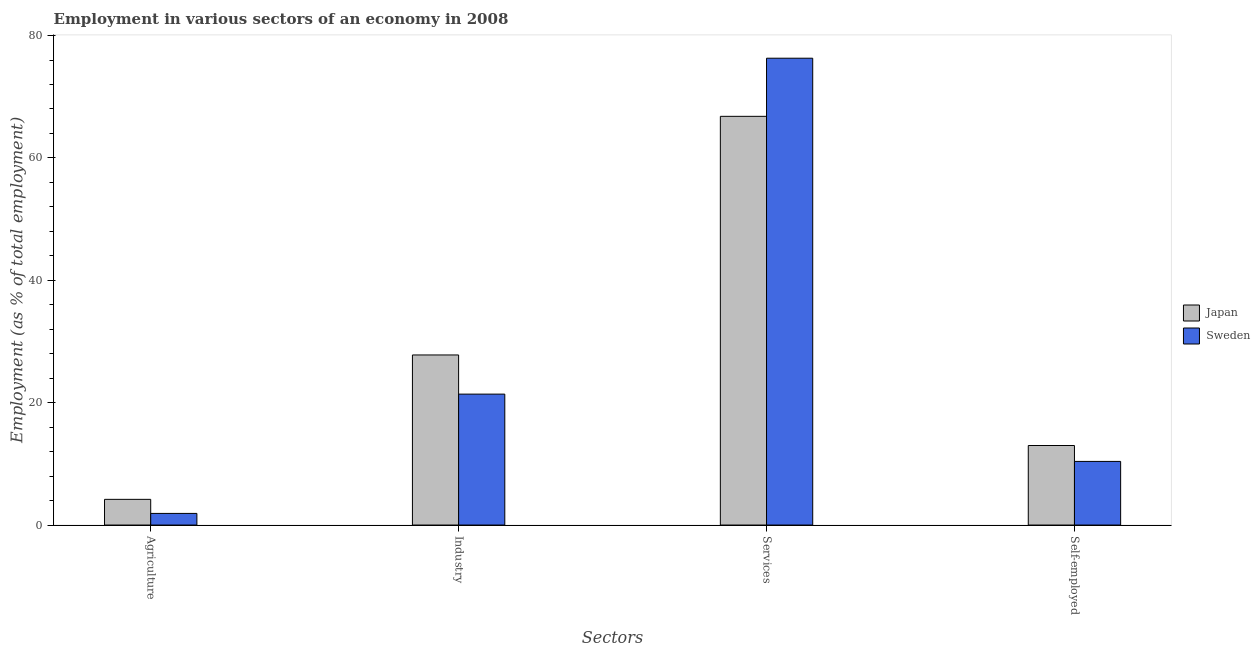How many different coloured bars are there?
Offer a terse response. 2. How many groups of bars are there?
Ensure brevity in your answer.  4. Are the number of bars per tick equal to the number of legend labels?
Your response must be concise. Yes. How many bars are there on the 2nd tick from the right?
Your response must be concise. 2. What is the label of the 3rd group of bars from the left?
Your answer should be very brief. Services. What is the percentage of workers in services in Sweden?
Ensure brevity in your answer.  76.3. Across all countries, what is the maximum percentage of workers in agriculture?
Give a very brief answer. 4.2. Across all countries, what is the minimum percentage of workers in industry?
Keep it short and to the point. 21.4. In which country was the percentage of workers in services maximum?
Offer a terse response. Sweden. In which country was the percentage of workers in agriculture minimum?
Offer a terse response. Sweden. What is the total percentage of workers in services in the graph?
Keep it short and to the point. 143.1. What is the difference between the percentage of workers in industry in Sweden and that in Japan?
Offer a terse response. -6.4. What is the difference between the percentage of self employed workers in Japan and the percentage of workers in industry in Sweden?
Provide a short and direct response. -8.4. What is the average percentage of workers in industry per country?
Your answer should be very brief. 24.6. What is the difference between the percentage of workers in agriculture and percentage of workers in industry in Japan?
Provide a short and direct response. -23.6. In how many countries, is the percentage of workers in industry greater than 56 %?
Give a very brief answer. 0. What is the ratio of the percentage of workers in services in Japan to that in Sweden?
Offer a very short reply. 0.88. Is the difference between the percentage of self employed workers in Japan and Sweden greater than the difference between the percentage of workers in services in Japan and Sweden?
Your answer should be compact. Yes. What is the difference between the highest and the second highest percentage of workers in agriculture?
Your answer should be compact. 2.3. What is the difference between the highest and the lowest percentage of self employed workers?
Provide a short and direct response. 2.6. In how many countries, is the percentage of workers in agriculture greater than the average percentage of workers in agriculture taken over all countries?
Give a very brief answer. 1. Is it the case that in every country, the sum of the percentage of workers in services and percentage of workers in industry is greater than the sum of percentage of workers in agriculture and percentage of self employed workers?
Your answer should be very brief. No. What does the 2nd bar from the left in Agriculture represents?
Offer a terse response. Sweden. How many bars are there?
Offer a very short reply. 8. Are the values on the major ticks of Y-axis written in scientific E-notation?
Offer a very short reply. No. Does the graph contain any zero values?
Give a very brief answer. No. How many legend labels are there?
Your answer should be compact. 2. What is the title of the graph?
Give a very brief answer. Employment in various sectors of an economy in 2008. Does "European Union" appear as one of the legend labels in the graph?
Your answer should be very brief. No. What is the label or title of the X-axis?
Offer a terse response. Sectors. What is the label or title of the Y-axis?
Offer a very short reply. Employment (as % of total employment). What is the Employment (as % of total employment) of Japan in Agriculture?
Keep it short and to the point. 4.2. What is the Employment (as % of total employment) in Sweden in Agriculture?
Your answer should be compact. 1.9. What is the Employment (as % of total employment) of Japan in Industry?
Your answer should be very brief. 27.8. What is the Employment (as % of total employment) of Sweden in Industry?
Your response must be concise. 21.4. What is the Employment (as % of total employment) of Japan in Services?
Ensure brevity in your answer.  66.8. What is the Employment (as % of total employment) in Sweden in Services?
Your response must be concise. 76.3. What is the Employment (as % of total employment) of Japan in Self-employed?
Give a very brief answer. 13. What is the Employment (as % of total employment) in Sweden in Self-employed?
Make the answer very short. 10.4. Across all Sectors, what is the maximum Employment (as % of total employment) in Japan?
Make the answer very short. 66.8. Across all Sectors, what is the maximum Employment (as % of total employment) of Sweden?
Ensure brevity in your answer.  76.3. Across all Sectors, what is the minimum Employment (as % of total employment) of Japan?
Your answer should be very brief. 4.2. Across all Sectors, what is the minimum Employment (as % of total employment) in Sweden?
Give a very brief answer. 1.9. What is the total Employment (as % of total employment) in Japan in the graph?
Ensure brevity in your answer.  111.8. What is the total Employment (as % of total employment) in Sweden in the graph?
Offer a terse response. 110. What is the difference between the Employment (as % of total employment) in Japan in Agriculture and that in Industry?
Ensure brevity in your answer.  -23.6. What is the difference between the Employment (as % of total employment) of Sweden in Agriculture and that in Industry?
Offer a terse response. -19.5. What is the difference between the Employment (as % of total employment) in Japan in Agriculture and that in Services?
Keep it short and to the point. -62.6. What is the difference between the Employment (as % of total employment) in Sweden in Agriculture and that in Services?
Your answer should be compact. -74.4. What is the difference between the Employment (as % of total employment) of Japan in Industry and that in Services?
Provide a short and direct response. -39. What is the difference between the Employment (as % of total employment) of Sweden in Industry and that in Services?
Your answer should be compact. -54.9. What is the difference between the Employment (as % of total employment) of Sweden in Industry and that in Self-employed?
Your response must be concise. 11. What is the difference between the Employment (as % of total employment) in Japan in Services and that in Self-employed?
Make the answer very short. 53.8. What is the difference between the Employment (as % of total employment) in Sweden in Services and that in Self-employed?
Give a very brief answer. 65.9. What is the difference between the Employment (as % of total employment) in Japan in Agriculture and the Employment (as % of total employment) in Sweden in Industry?
Provide a succinct answer. -17.2. What is the difference between the Employment (as % of total employment) in Japan in Agriculture and the Employment (as % of total employment) in Sweden in Services?
Ensure brevity in your answer.  -72.1. What is the difference between the Employment (as % of total employment) in Japan in Industry and the Employment (as % of total employment) in Sweden in Services?
Provide a short and direct response. -48.5. What is the difference between the Employment (as % of total employment) in Japan in Services and the Employment (as % of total employment) in Sweden in Self-employed?
Make the answer very short. 56.4. What is the average Employment (as % of total employment) of Japan per Sectors?
Keep it short and to the point. 27.95. What is the difference between the Employment (as % of total employment) in Japan and Employment (as % of total employment) in Sweden in Agriculture?
Your response must be concise. 2.3. What is the difference between the Employment (as % of total employment) of Japan and Employment (as % of total employment) of Sweden in Industry?
Your answer should be very brief. 6.4. What is the ratio of the Employment (as % of total employment) of Japan in Agriculture to that in Industry?
Your response must be concise. 0.15. What is the ratio of the Employment (as % of total employment) in Sweden in Agriculture to that in Industry?
Your answer should be very brief. 0.09. What is the ratio of the Employment (as % of total employment) of Japan in Agriculture to that in Services?
Your answer should be compact. 0.06. What is the ratio of the Employment (as % of total employment) in Sweden in Agriculture to that in Services?
Keep it short and to the point. 0.02. What is the ratio of the Employment (as % of total employment) of Japan in Agriculture to that in Self-employed?
Provide a short and direct response. 0.32. What is the ratio of the Employment (as % of total employment) in Sweden in Agriculture to that in Self-employed?
Offer a very short reply. 0.18. What is the ratio of the Employment (as % of total employment) of Japan in Industry to that in Services?
Ensure brevity in your answer.  0.42. What is the ratio of the Employment (as % of total employment) in Sweden in Industry to that in Services?
Provide a succinct answer. 0.28. What is the ratio of the Employment (as % of total employment) of Japan in Industry to that in Self-employed?
Provide a succinct answer. 2.14. What is the ratio of the Employment (as % of total employment) in Sweden in Industry to that in Self-employed?
Offer a terse response. 2.06. What is the ratio of the Employment (as % of total employment) of Japan in Services to that in Self-employed?
Your answer should be compact. 5.14. What is the ratio of the Employment (as % of total employment) of Sweden in Services to that in Self-employed?
Offer a terse response. 7.34. What is the difference between the highest and the second highest Employment (as % of total employment) of Sweden?
Make the answer very short. 54.9. What is the difference between the highest and the lowest Employment (as % of total employment) in Japan?
Ensure brevity in your answer.  62.6. What is the difference between the highest and the lowest Employment (as % of total employment) in Sweden?
Keep it short and to the point. 74.4. 